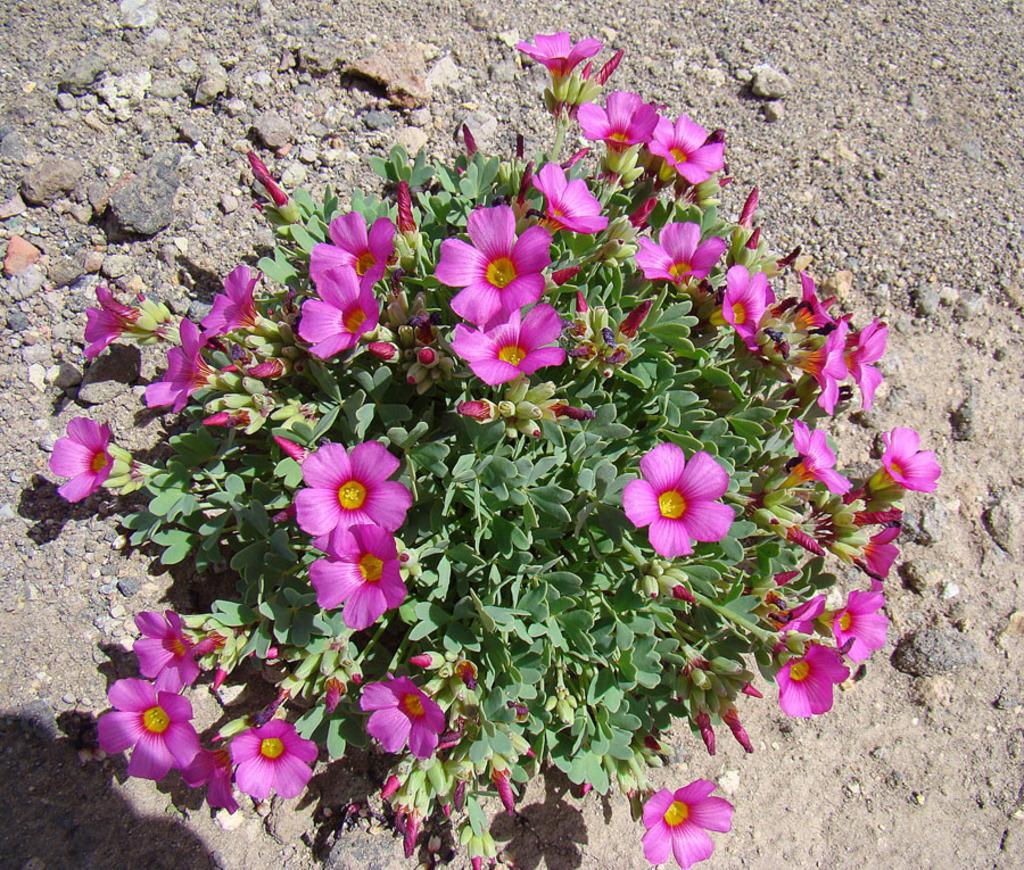What type of plants are present in the image? The plants in the image have flowers and buds. Can you describe the flowers on the plants? The flowers on the plants are visible in the image. What else can be seen on the ground in the image? There are stones on the ground in the image. What rhythm do the flowers follow as they sway in the image? The flowers do not sway in the image, and there is no rhythm associated with them. 